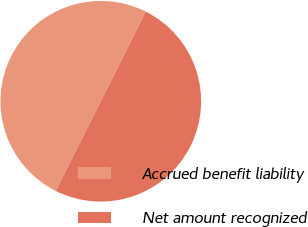Convert chart. <chart><loc_0><loc_0><loc_500><loc_500><pie_chart><fcel>Accrued benefit liability<fcel>Net amount recognized<nl><fcel>50.0%<fcel>50.0%<nl></chart> 